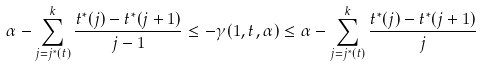<formula> <loc_0><loc_0><loc_500><loc_500>\alpha - \sum _ { j = j ^ { * } ( t ) } ^ { k } \frac { t ^ { * } ( j ) - t ^ { * } ( j + 1 ) } { j - 1 } \leq - \gamma ( 1 , t , \alpha ) \leq \alpha - \sum _ { j = j ^ { * } ( t ) } ^ { k } \frac { t ^ { * } ( j ) - t ^ { * } ( j + 1 ) } { j }</formula> 